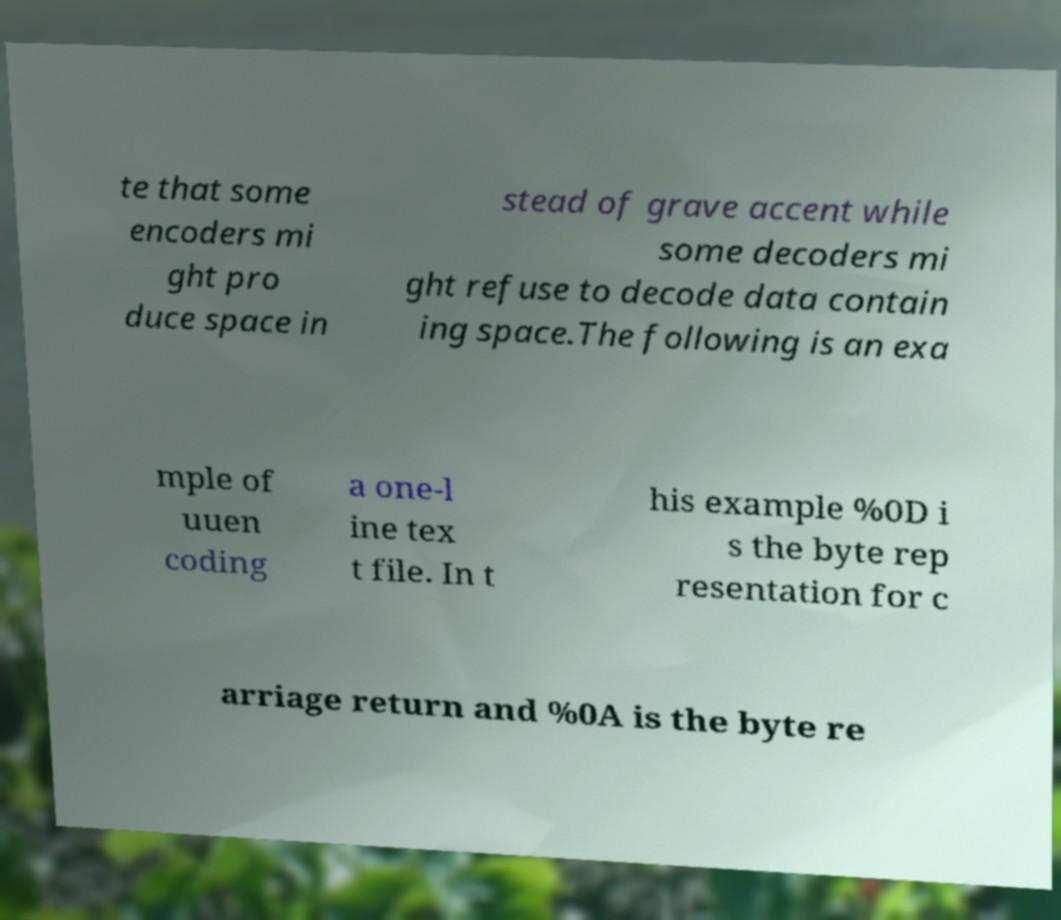Can you accurately transcribe the text from the provided image for me? te that some encoders mi ght pro duce space in stead of grave accent while some decoders mi ght refuse to decode data contain ing space.The following is an exa mple of uuen coding a one-l ine tex t file. In t his example %0D i s the byte rep resentation for c arriage return and %0A is the byte re 